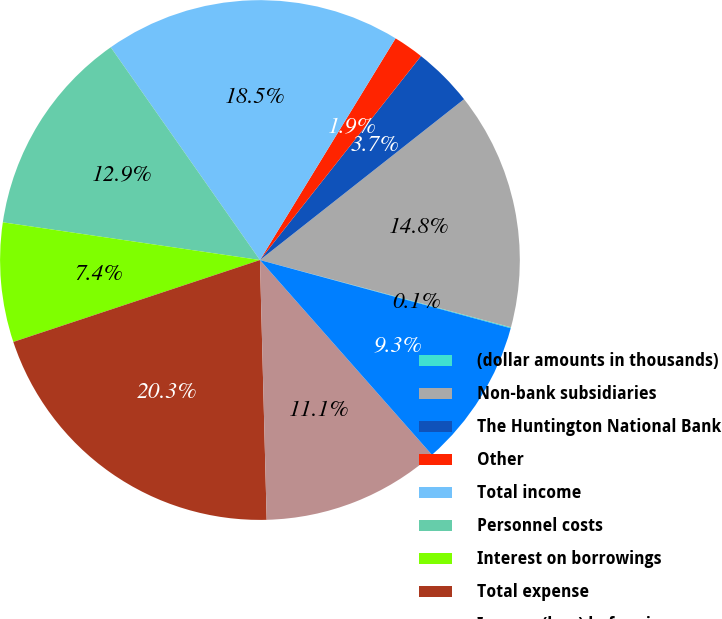Convert chart. <chart><loc_0><loc_0><loc_500><loc_500><pie_chart><fcel>(dollar amounts in thousands)<fcel>Non-bank subsidiaries<fcel>The Huntington National Bank<fcel>Other<fcel>Total income<fcel>Personnel costs<fcel>Interest on borrowings<fcel>Total expense<fcel>Income (loss) before income<fcel>Provision (benefit) for income<nl><fcel>0.06%<fcel>14.79%<fcel>3.74%<fcel>1.9%<fcel>18.47%<fcel>12.95%<fcel>7.42%<fcel>20.31%<fcel>11.1%<fcel>9.26%<nl></chart> 